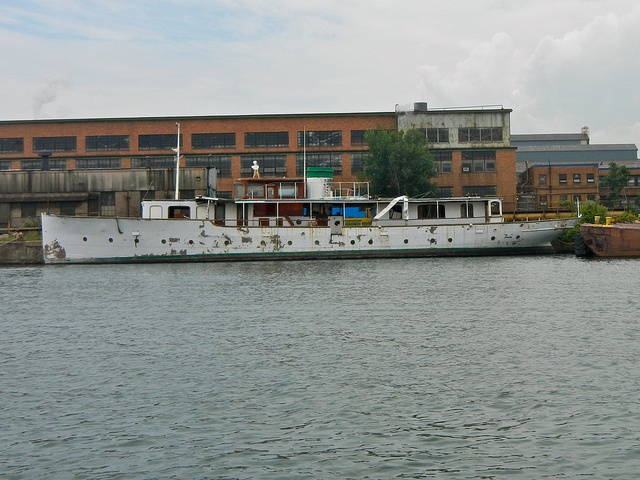Describe the objects in this image and their specific colors. I can see boat in lightblue, darkgray, black, gray, and darkgreen tones and boat in lightblue, maroon, black, and gray tones in this image. 